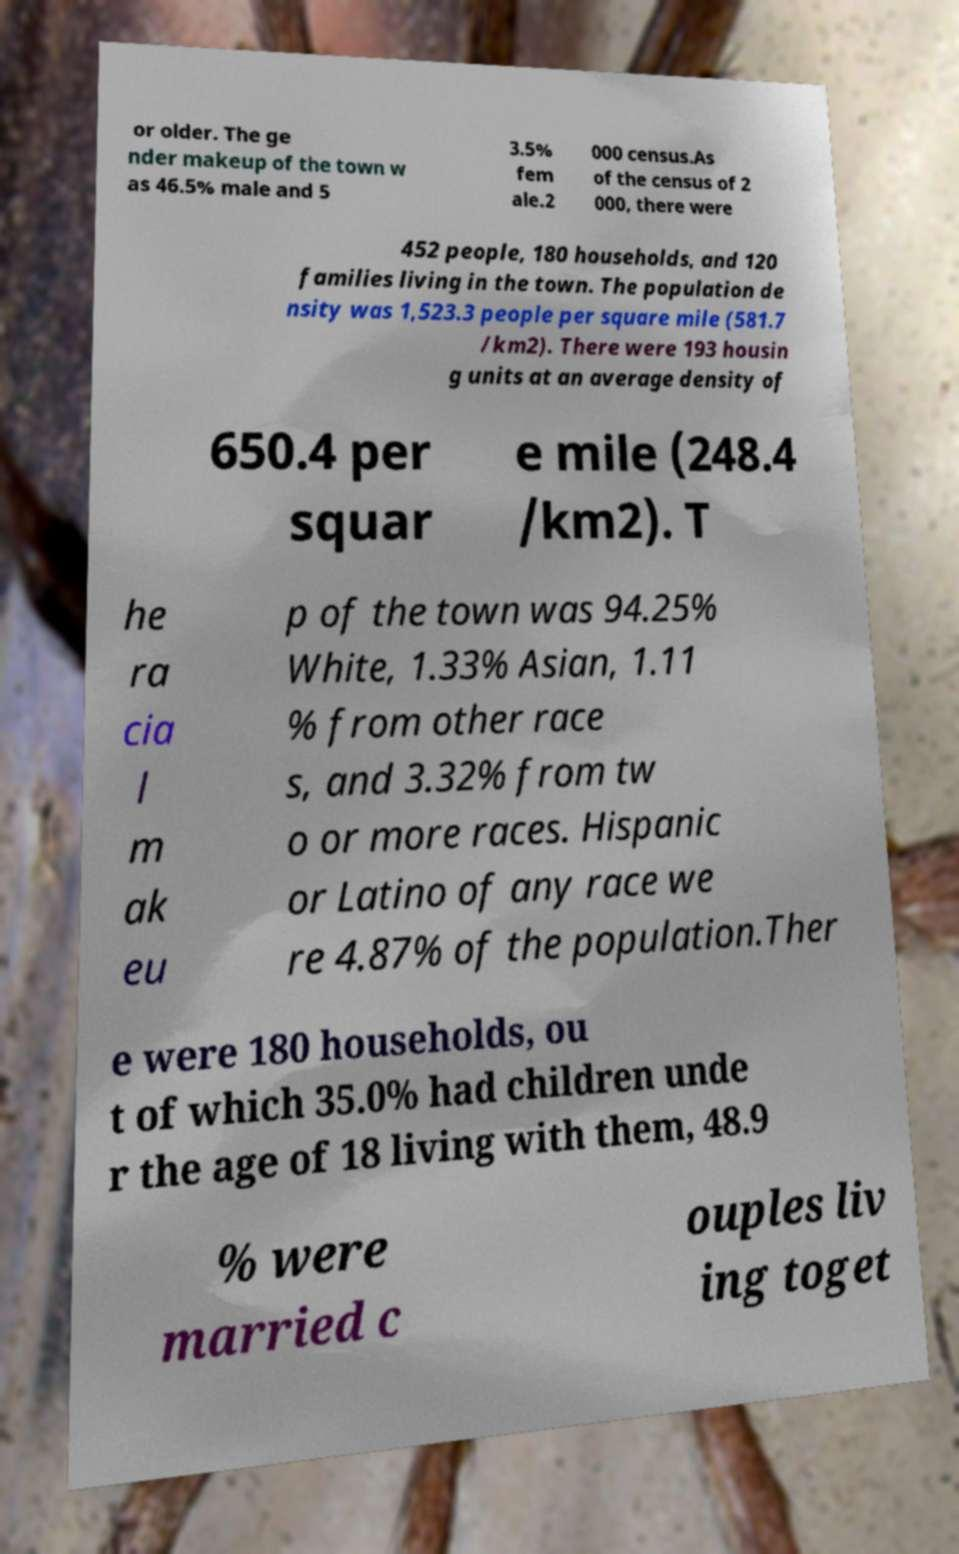Could you assist in decoding the text presented in this image and type it out clearly? or older. The ge nder makeup of the town w as 46.5% male and 5 3.5% fem ale.2 000 census.As of the census of 2 000, there were 452 people, 180 households, and 120 families living in the town. The population de nsity was 1,523.3 people per square mile (581.7 /km2). There were 193 housin g units at an average density of 650.4 per squar e mile (248.4 /km2). T he ra cia l m ak eu p of the town was 94.25% White, 1.33% Asian, 1.11 % from other race s, and 3.32% from tw o or more races. Hispanic or Latino of any race we re 4.87% of the population.Ther e were 180 households, ou t of which 35.0% had children unde r the age of 18 living with them, 48.9 % were married c ouples liv ing toget 